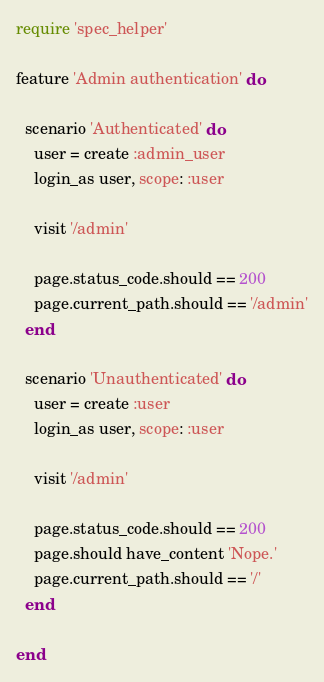<code> <loc_0><loc_0><loc_500><loc_500><_Ruby_>require 'spec_helper'

feature 'Admin authentication' do

  scenario 'Authenticated' do
    user = create :admin_user
    login_as user, scope: :user

    visit '/admin'

    page.status_code.should == 200
    page.current_path.should == '/admin'
  end

  scenario 'Unauthenticated' do
    user = create :user
    login_as user, scope: :user

    visit '/admin'

    page.status_code.should == 200
    page.should have_content 'Nope.'
    page.current_path.should == '/'
  end

end
</code> 